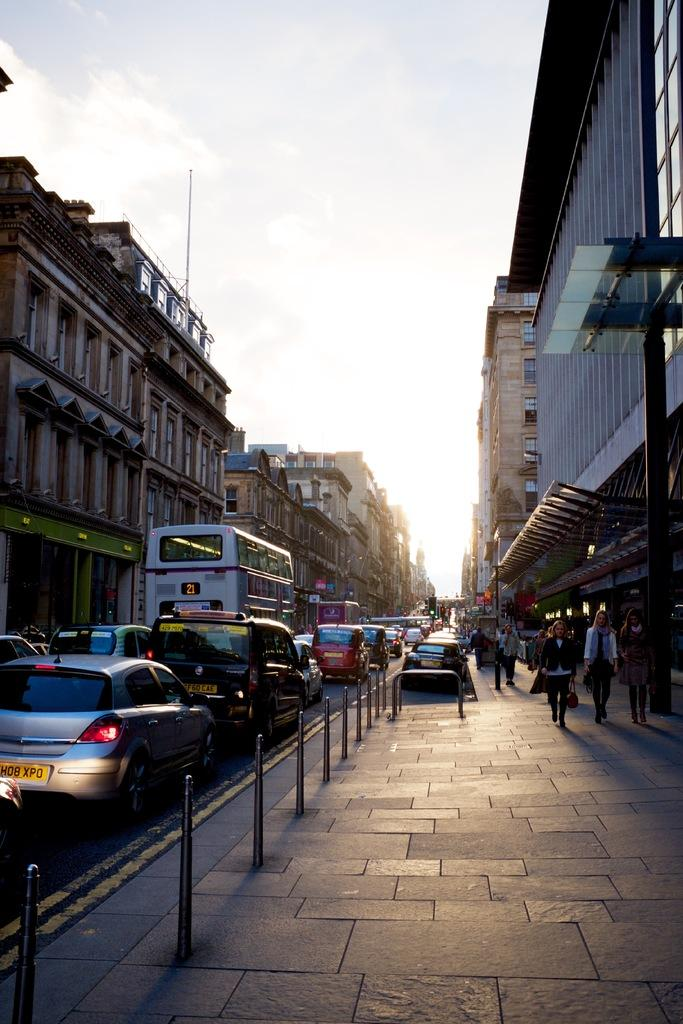Provide a one-sentence caption for the provided image. A congested street and a car with a yellow license plate HD8 XPD. 